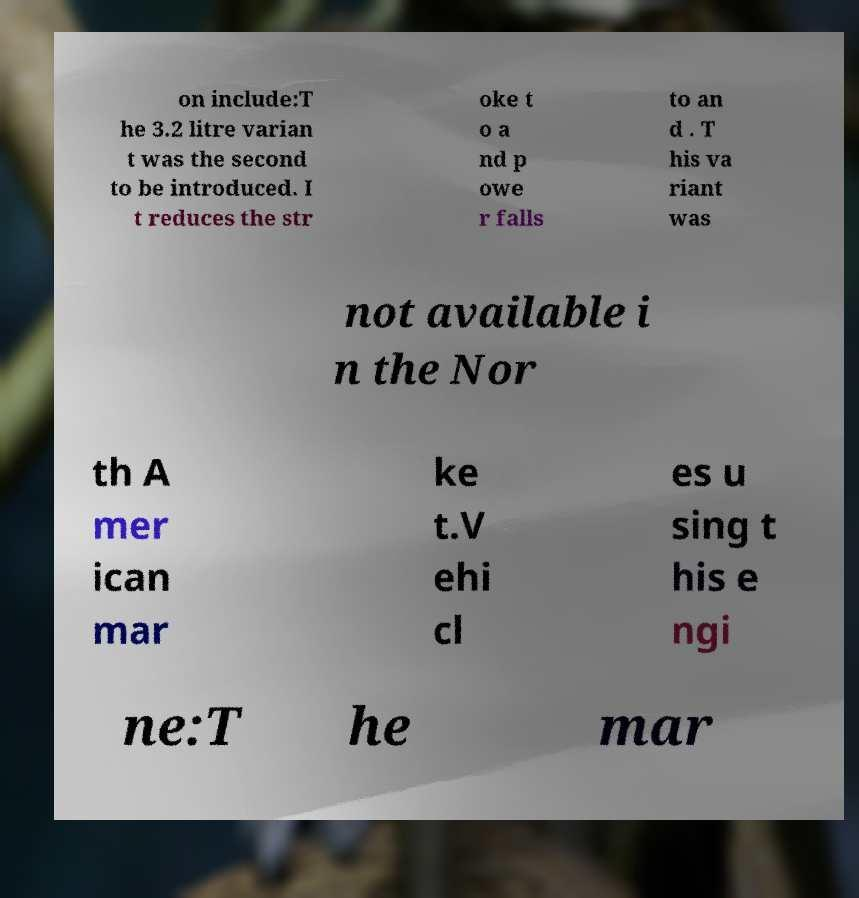For documentation purposes, I need the text within this image transcribed. Could you provide that? on include:T he 3.2 litre varian t was the second to be introduced. I t reduces the str oke t o a nd p owe r falls to an d . T his va riant was not available i n the Nor th A mer ican mar ke t.V ehi cl es u sing t his e ngi ne:T he mar 